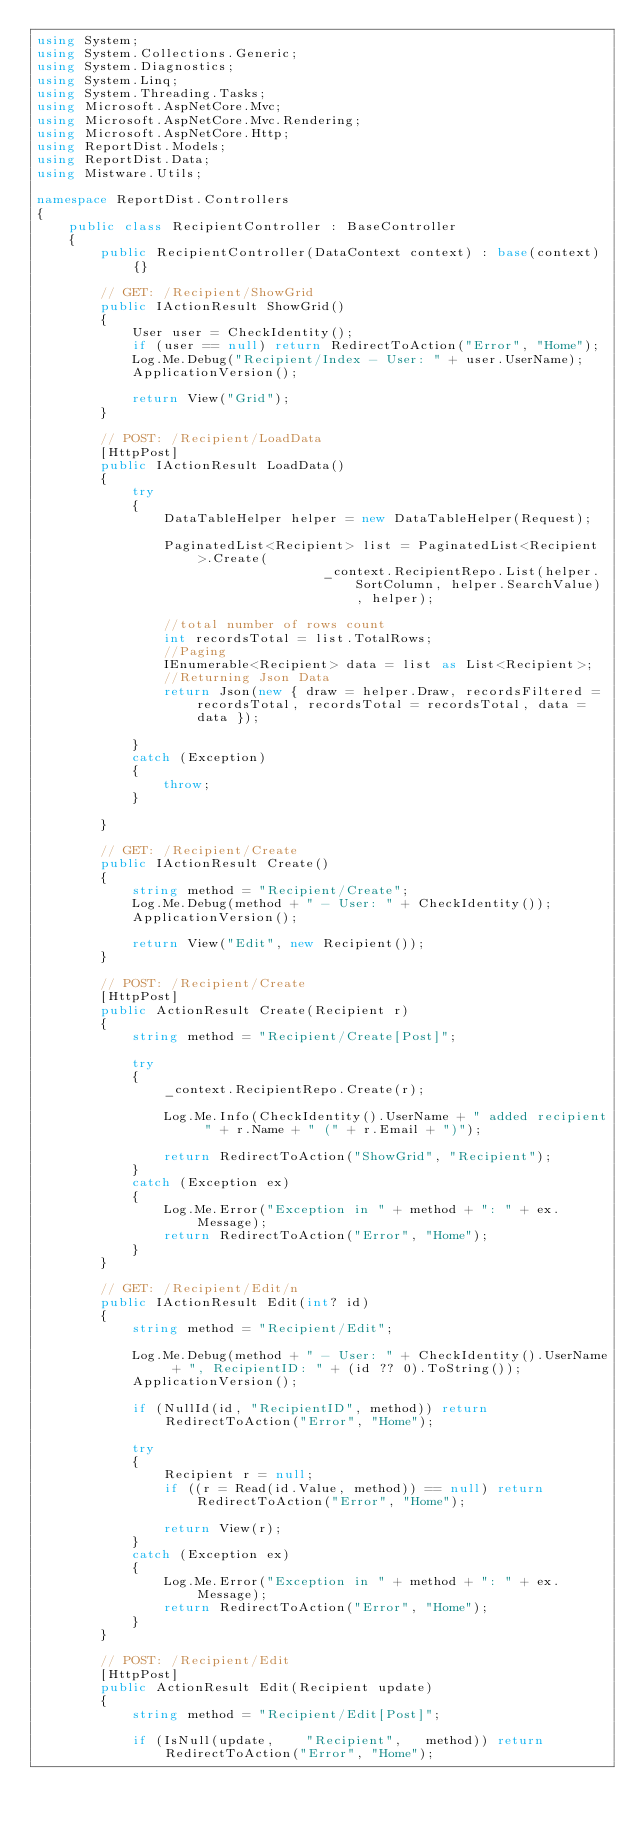<code> <loc_0><loc_0><loc_500><loc_500><_C#_>using System;
using System.Collections.Generic;
using System.Diagnostics;
using System.Linq;
using System.Threading.Tasks;
using Microsoft.AspNetCore.Mvc;
using Microsoft.AspNetCore.Mvc.Rendering;
using Microsoft.AspNetCore.Http;
using ReportDist.Models;
using ReportDist.Data;
using Mistware.Utils;

namespace ReportDist.Controllers
{
    public class RecipientController : BaseController
    {
        public RecipientController(DataContext context) : base(context) {}
            
        // GET: /Recipient/ShowGrid 
        public IActionResult ShowGrid()  
        {  
            User user = CheckIdentity();
            if (user == null) return RedirectToAction("Error", "Home");
            Log.Me.Debug("Recipient/Index - User: " + user.UserName);
            ApplicationVersion();

            return View("Grid");  
        } 

        // POST: /Recipient/LoadData
        [HttpPost]
        public IActionResult LoadData()  
        {  
            try  
            { 
                DataTableHelper helper = new DataTableHelper(Request);
      
                PaginatedList<Recipient> list = PaginatedList<Recipient>.Create(
                                    _context.RecipientRepo.List(helper.SortColumn, helper.SearchValue), helper);

                //total number of rows count   
                int recordsTotal = list.TotalRows;  
                //Paging   
                IEnumerable<Recipient> data = list as List<Recipient>;   
                //Returning Json Data  
                return Json(new { draw = helper.Draw, recordsFiltered = recordsTotal, recordsTotal = recordsTotal, data = data });  

            }  
            catch (Exception)  
            {  
                throw;  
            }  

        }

        // GET: /Recipient/Create
        public IActionResult Create()
        {
            string method = "Recipient/Create";
            Log.Me.Debug(method + " - User: " + CheckIdentity());
            ApplicationVersion();
    
            return View("Edit", new Recipient());
        }

        // POST: /Recipient/Create
        [HttpPost]
        public ActionResult Create(Recipient r)
        {
            string method = "Recipient/Create[Post]";

            try
            {   
                _context.RecipientRepo.Create(r);

                Log.Me.Info(CheckIdentity().UserName + " added recipient " + r.Name + " (" + r.Email + ")");

                return RedirectToAction("ShowGrid", "Recipient");   
            }
            catch (Exception ex)
            {
                Log.Me.Error("Exception in " + method + ": " + ex.Message);
                return RedirectToAction("Error", "Home"); 
            }
        }

        // GET: /Recipient/Edit/n
        public IActionResult Edit(int? id)
        {
            string method = "Recipient/Edit";

            Log.Me.Debug(method + " - User: " + CheckIdentity().UserName + ", RecipientID: " + (id ?? 0).ToString());
            ApplicationVersion();

            if (NullId(id, "RecipientID", method)) return RedirectToAction("Error", "Home"); 

            try
            {
                Recipient r = null;
                if ((r = Read(id.Value, method)) == null) return RedirectToAction("Error", "Home"); 
               
                return View(r);
            }
            catch (Exception ex)
            {
                Log.Me.Error("Exception in " + method + ": " + ex.Message);
                return RedirectToAction("Error", "Home"); 
            }
        }

        // POST: /Recipient/Edit
        [HttpPost]
        public ActionResult Edit(Recipient update)
        {
            string method = "Recipient/Edit[Post]";

            if (IsNull(update,    "Recipient",   method)) return RedirectToAction("Error", "Home");     </code> 